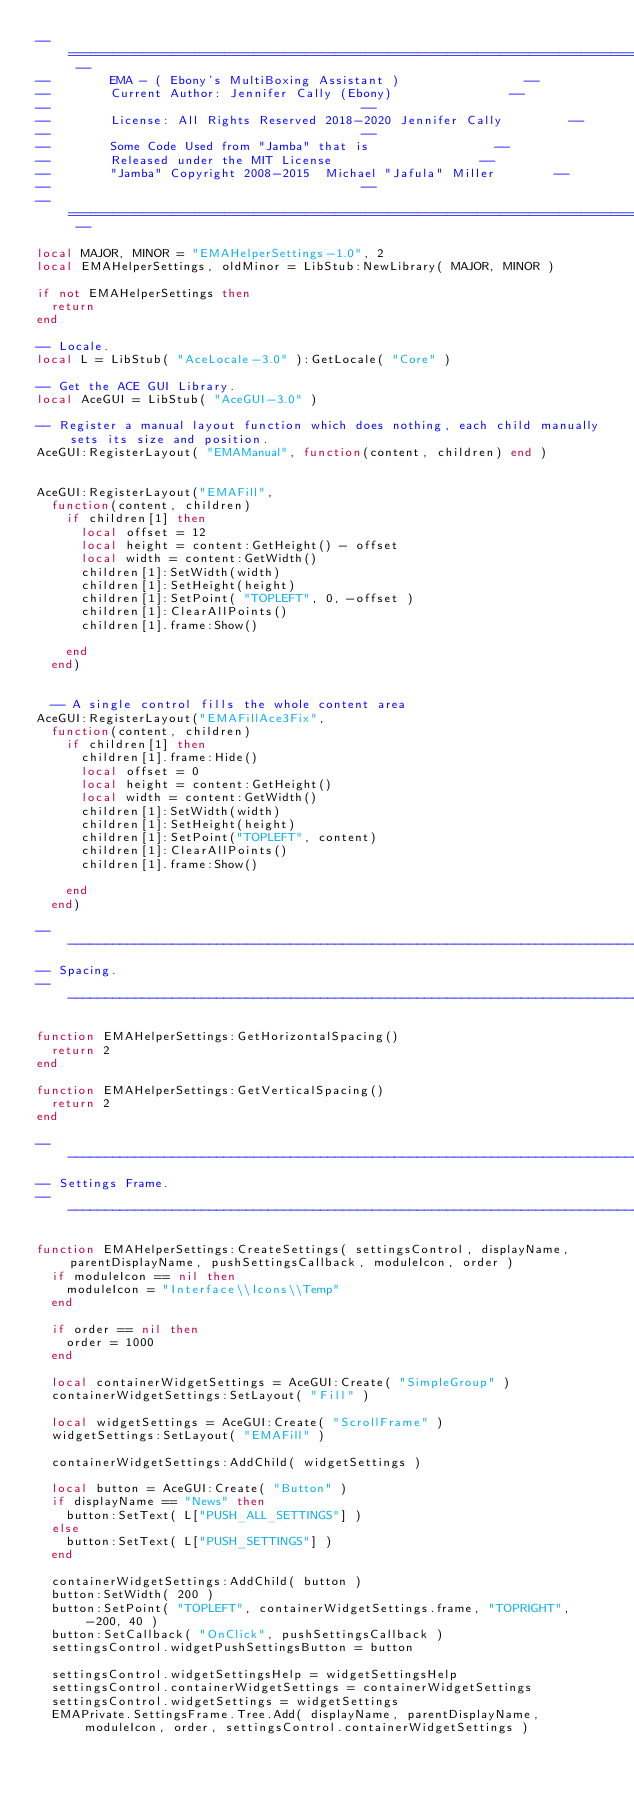Convert code to text. <code><loc_0><loc_0><loc_500><loc_500><_Lua_>-- ================================================================================ --
--				EMA - ( Ebony's MultiBoxing Assistant )    							--
--				Current Author: Jennifer Cally (Ebony)								--
--																					--
--				License: All Rights Reserved 2018-2020 Jennifer Cally					--
--																					--
--				Some Code Used from "Jamba" that is 								--
--				Released under the MIT License 										--
--				"Jamba" Copyright 2008-2015  Michael "Jafula" Miller				--
--																					--
-- ================================================================================ --

local MAJOR, MINOR = "EMAHelperSettings-1.0", 2
local EMAHelperSettings, oldMinor = LibStub:NewLibrary( MAJOR, MINOR )

if not EMAHelperSettings then 
	return 
end

-- Locale.
local L = LibStub( "AceLocale-3.0" ):GetLocale( "Core" )

-- Get the ACE GUI Library.
local AceGUI = LibStub( "AceGUI-3.0" )

-- Register a manual layout function which does nothing, each child manually sets its size and position.
AceGUI:RegisterLayout( "EMAManual", function(content, children) end )


AceGUI:RegisterLayout("EMAFill",
	function(content, children)
		if children[1] then
			local offset = 12
			local height = content:GetHeight() - offset
			local width = content:GetWidth()
			children[1]:SetWidth(width)
			children[1]:SetHeight(height)
			children[1]:SetPoint( "TOPLEFT", 0, -offset )
			children[1]:ClearAllPoints()
			children[1].frame:Show()
			
		end
	end)


	-- A single control fills the whole content area
AceGUI:RegisterLayout("EMAFillAce3Fix",
	function(content, children)
		if children[1] then
			children[1].frame:Hide()
			local offset = 0
			local height = content:GetHeight()
			local width = content:GetWidth()
			children[1]:SetWidth(width)
			children[1]:SetHeight(height)
			children[1]:SetPoint("TOPLEFT", content)
			children[1]:ClearAllPoints()
			children[1].frame:Show()
			
		end
	end)
	
-------------------------------------------------------------------------------------------------------------
-- Spacing.
-------------------------------------------------------------------------------------------------------------

function EMAHelperSettings:GetHorizontalSpacing()
	return 2
end

function EMAHelperSettings:GetVerticalSpacing()
	return 2
end

-------------------------------------------------------------------------------------------------------------
-- Settings Frame.
-------------------------------------------------------------------------------------------------------------

function EMAHelperSettings:CreateSettings( settingsControl, displayName, parentDisplayName, pushSettingsCallback, moduleIcon, order )
	if moduleIcon == nil then
		moduleIcon = "Interface\\Icons\\Temp"
	end	
	
	if order == nil then
		order = 1000
	end	
	
	local containerWidgetSettings = AceGUI:Create( "SimpleGroup" )
	containerWidgetSettings:SetLayout( "Fill" )
	
	local widgetSettings = AceGUI:Create( "ScrollFrame" )
	widgetSettings:SetLayout( "EMAFill" )
	
	containerWidgetSettings:AddChild( widgetSettings )
	
	local button = AceGUI:Create( "Button" ) 
	if displayName == "News" then
		button:SetText( L["PUSH_ALL_SETTINGS"] )
	else	
		button:SetText( L["PUSH_SETTINGS"] )
	end
	
	containerWidgetSettings:AddChild( button )
	button:SetWidth( 200 )
	button:SetPoint( "TOPLEFT", containerWidgetSettings.frame, "TOPRIGHT", -200, 40 )
	button:SetCallback( "OnClick", pushSettingsCallback )
	settingsControl.widgetPushSettingsButton = button

	settingsControl.widgetSettingsHelp = widgetSettingsHelp
	settingsControl.containerWidgetSettings = containerWidgetSettings
	settingsControl.widgetSettings = widgetSettings
	EMAPrivate.SettingsFrame.Tree.Add( displayName, parentDisplayName, moduleIcon, order, settingsControl.containerWidgetSettings )</code> 